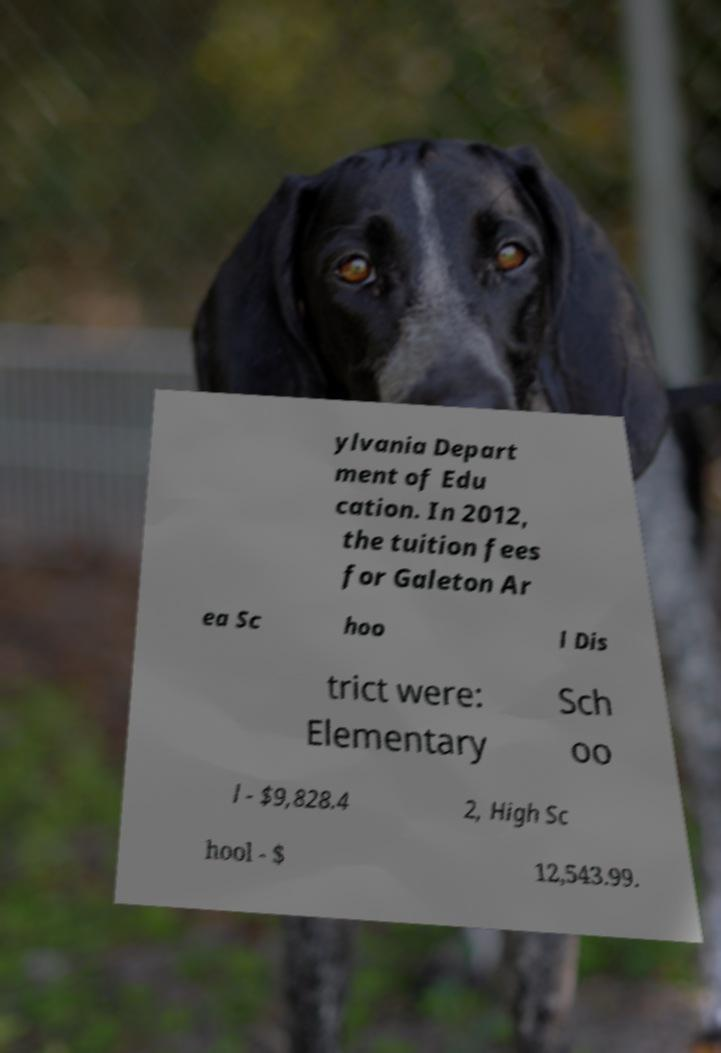Could you assist in decoding the text presented in this image and type it out clearly? ylvania Depart ment of Edu cation. In 2012, the tuition fees for Galeton Ar ea Sc hoo l Dis trict were: Elementary Sch oo l - $9,828.4 2, High Sc hool - $ 12,543.99. 